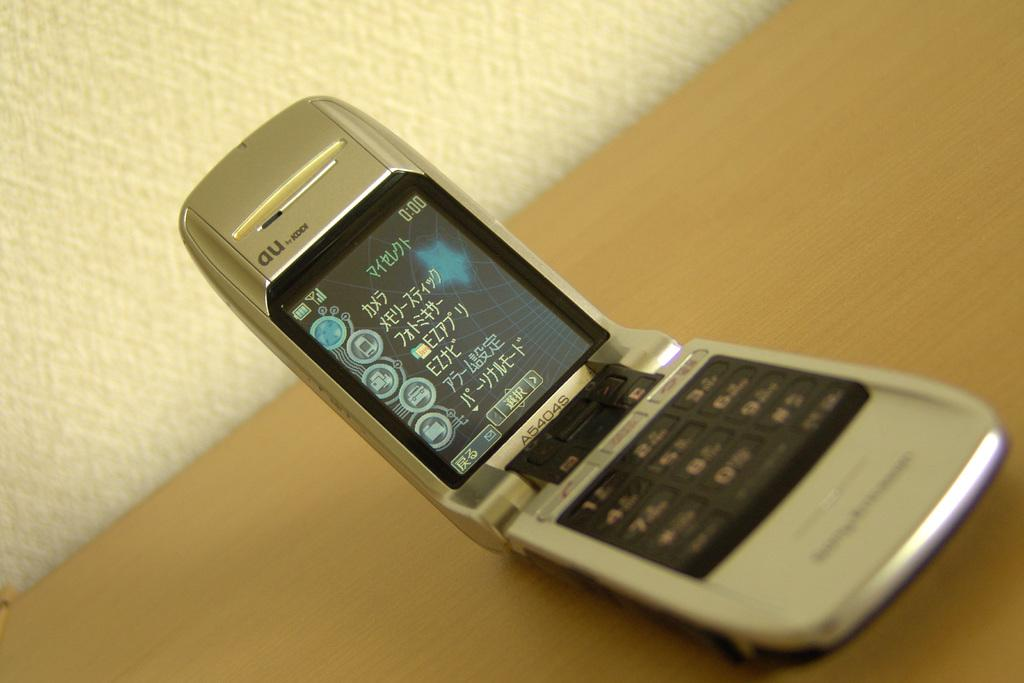<image>
Create a compact narrative representing the image presented. The small silver flip phone that is open is an au by kddi. 